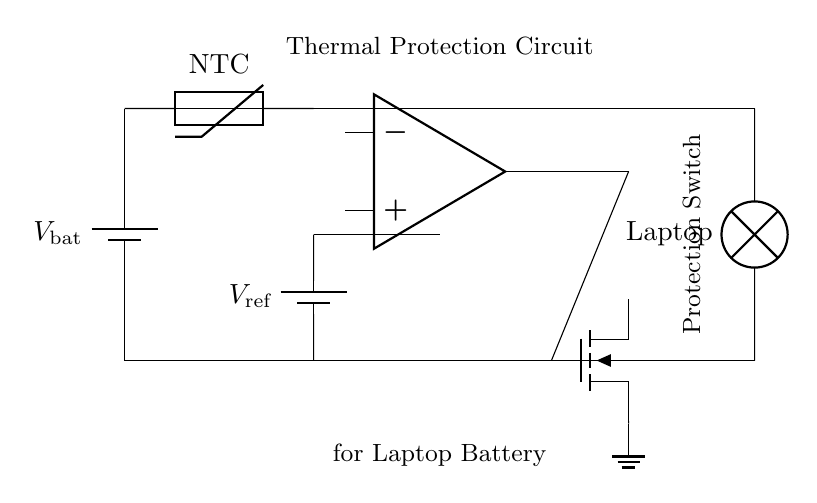What type of protection is implemented in this circuit? The circuit is designed for thermal protection, which is indicated by the presence of a thermistor and an op-amp comparator that monitor temperature.
Answer: Thermal protection What component is used to sense temperature? The component that senses temperature is the thermistor, specifically a Negative Temperature Coefficient (NTC) thermistor, which decreases resistance as temperature rises.
Answer: Thermistor What is the role of the comparator? The comparator compares the voltage from the thermistor to a reference voltage to determine if the battery's temperature exceeds a predefined threshold, triggering the MOSFET to cut off power if necessary.
Answer: Compare voltages How does the circuit react if the temperature exceeds the threshold? If the temperature exceeds the defined threshold, the comparator output will change state, activating the MOSFET to disconnect the load from the battery to prevent overheating.
Answer: Disconnect load What is the voltage level of the reference voltage in this circuit? The reference voltage, denoted as V_ref, is provided by a battery in the circuit which sets the threshold for the comparator. The specific value isn't shown in the diagram, but it serves as a reference for determining the temperature limit.
Answer: V_ref Which component acts as the load in this thermal protection circuit? The load in this circuit is represented by the lamp labeled "Laptop," which simulates the power draw of a laptop battery connected to the circuit.
Answer: Laptop 